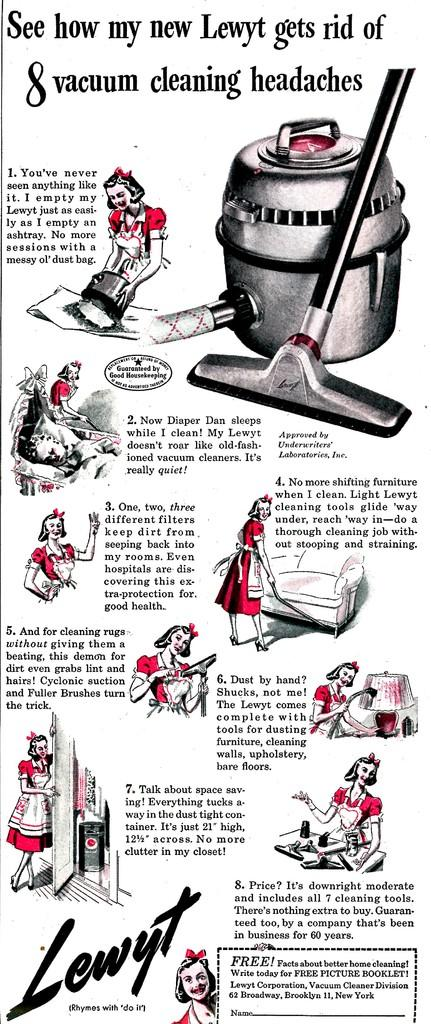<image>
Write a terse but informative summary of the picture. A old advertisement that shows how to use a vacuum cleaner. 